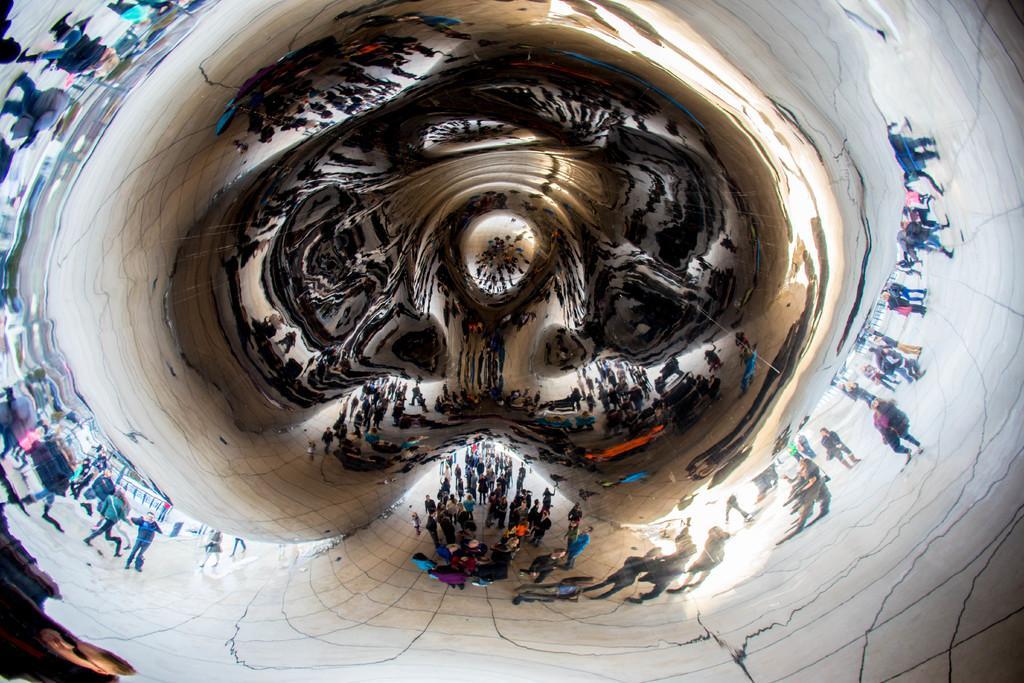Describe this image in one or two sentences. This is a cloud gate. On this cloud gate we can see the reflection of persons. 